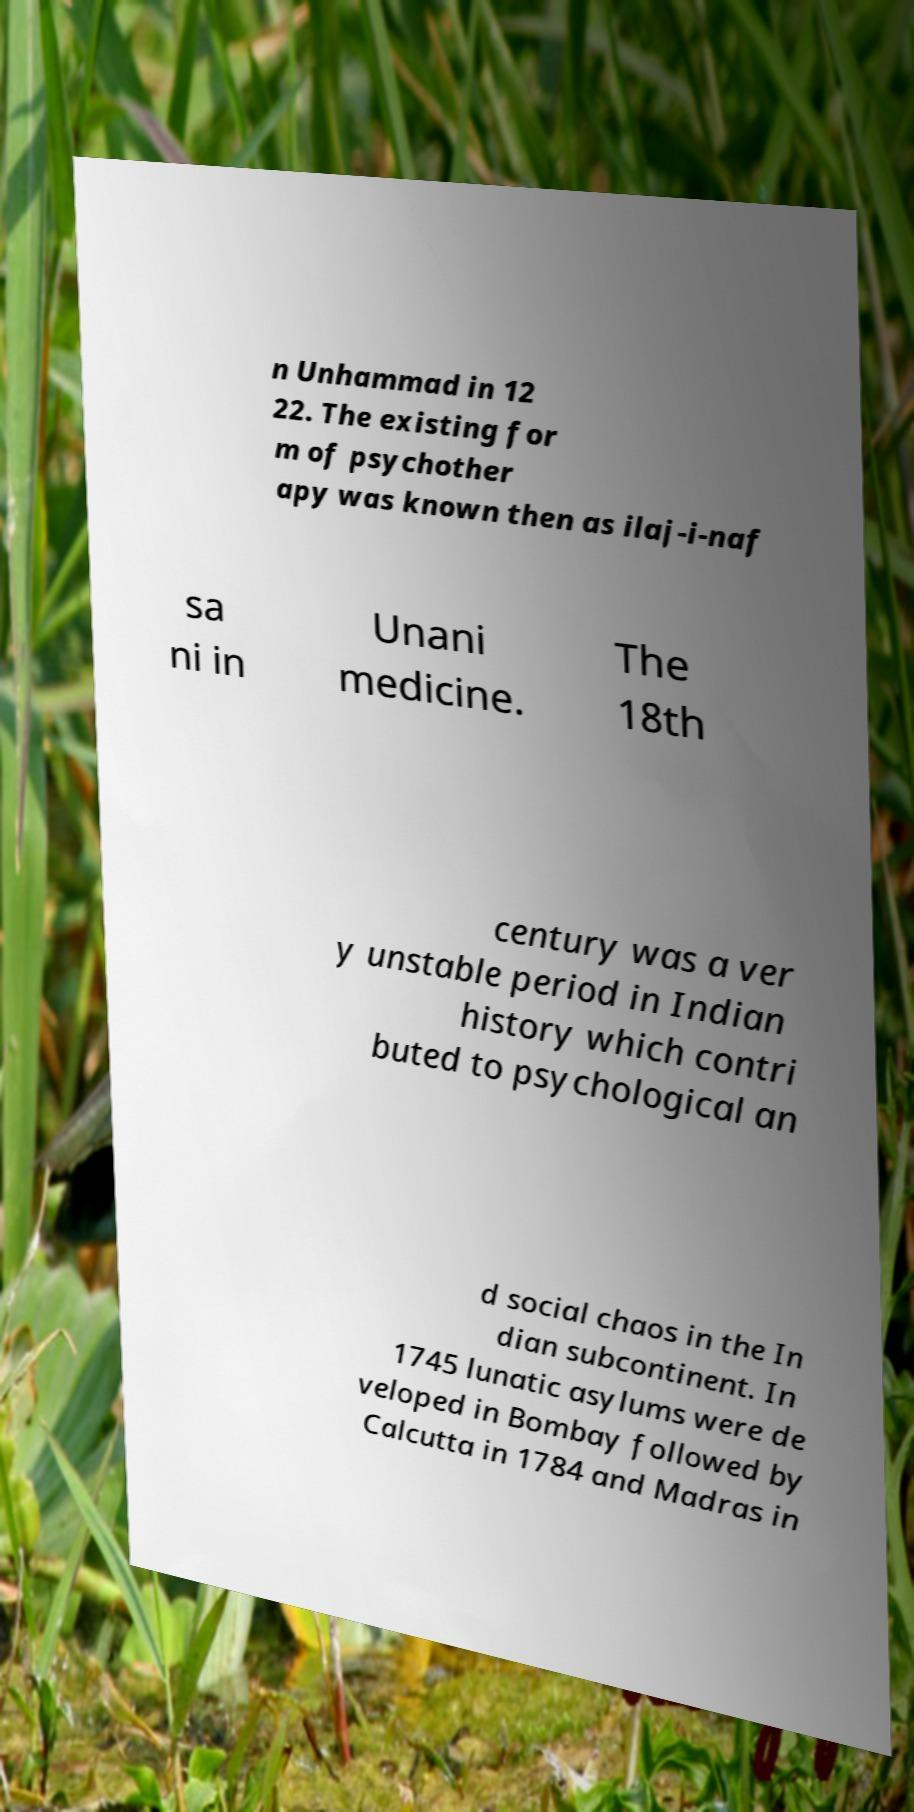There's text embedded in this image that I need extracted. Can you transcribe it verbatim? n Unhammad in 12 22. The existing for m of psychother apy was known then as ilaj-i-naf sa ni in Unani medicine. The 18th century was a ver y unstable period in Indian history which contri buted to psychological an d social chaos in the In dian subcontinent. In 1745 lunatic asylums were de veloped in Bombay followed by Calcutta in 1784 and Madras in 